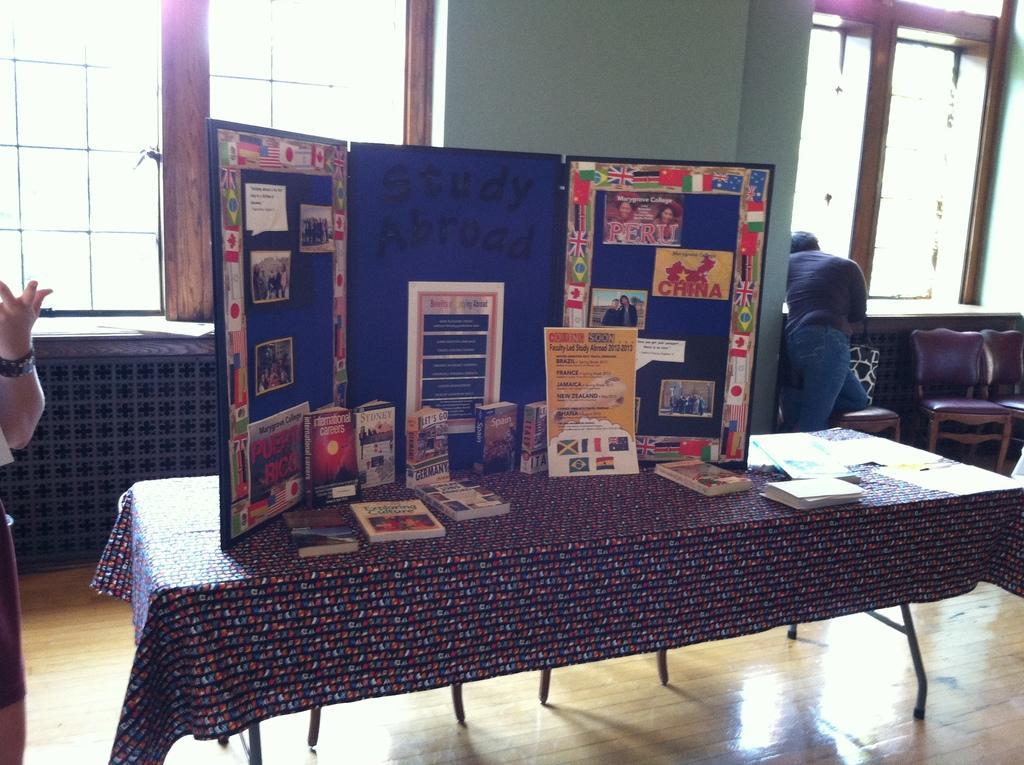Can you describe this image briefly? This picture is clicked inside the room. Here, we see a table on which many books, paper, pen and a board containing many charts on it, are placed on the table. Behind that, we see windows. Beside that, we see green wall. On the left corner, we see man in black t-shirt is standing near the window and beside him, we see two chairs. 